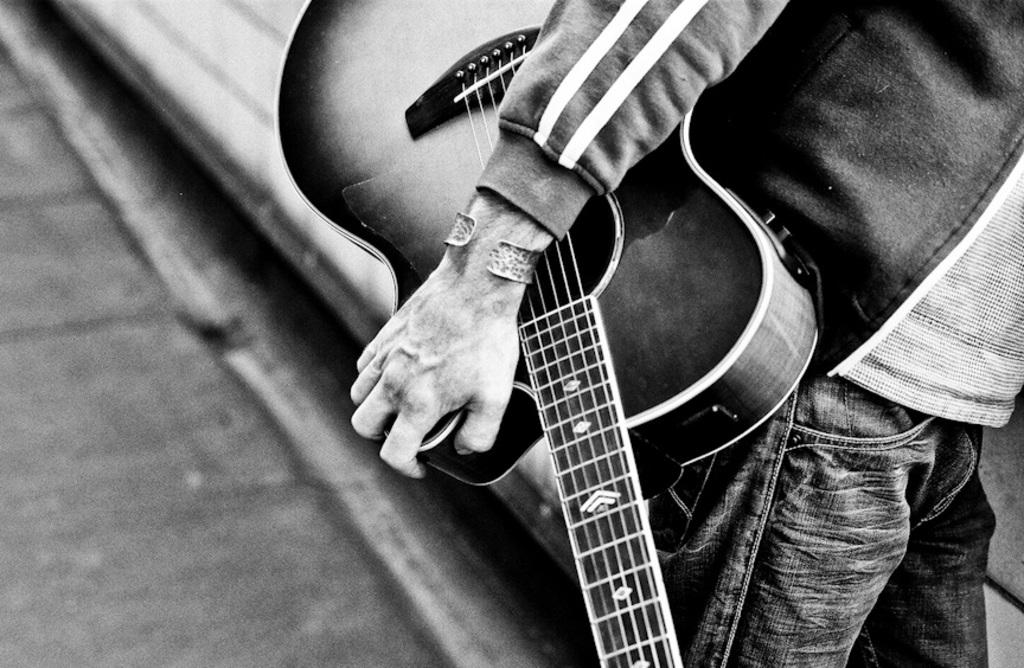What is the main subject of the image? There is a person in the image. What is the person holding in his hand? The person is holding a guitar in his hand. What type of noise can be heard coming from the nest in the image? There is no nest present in the image, so it is not possible to determine what, if any, noise might be heard. 